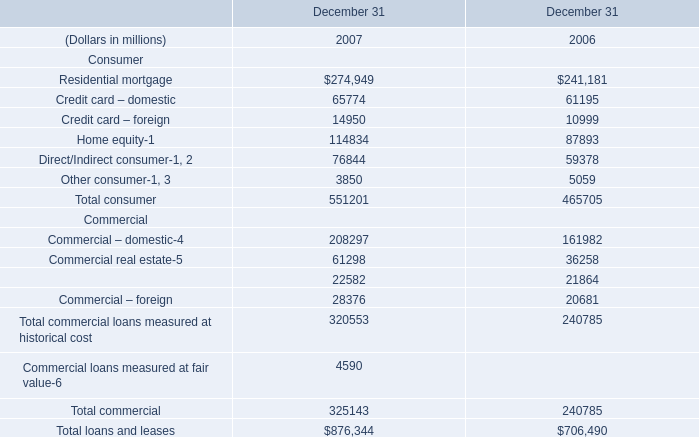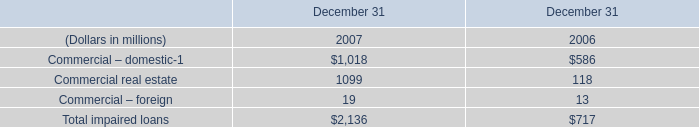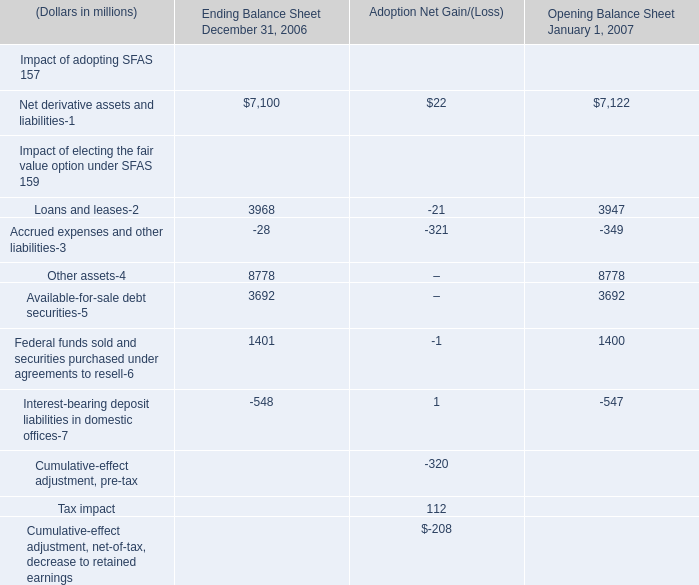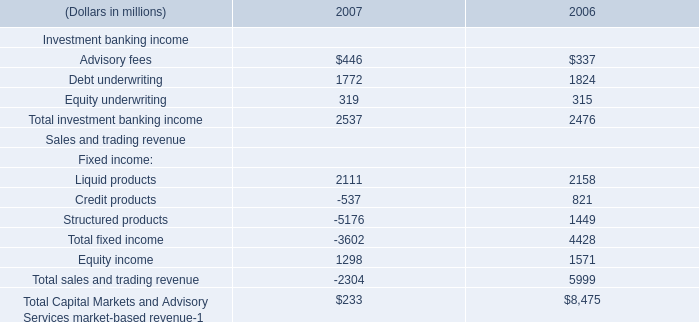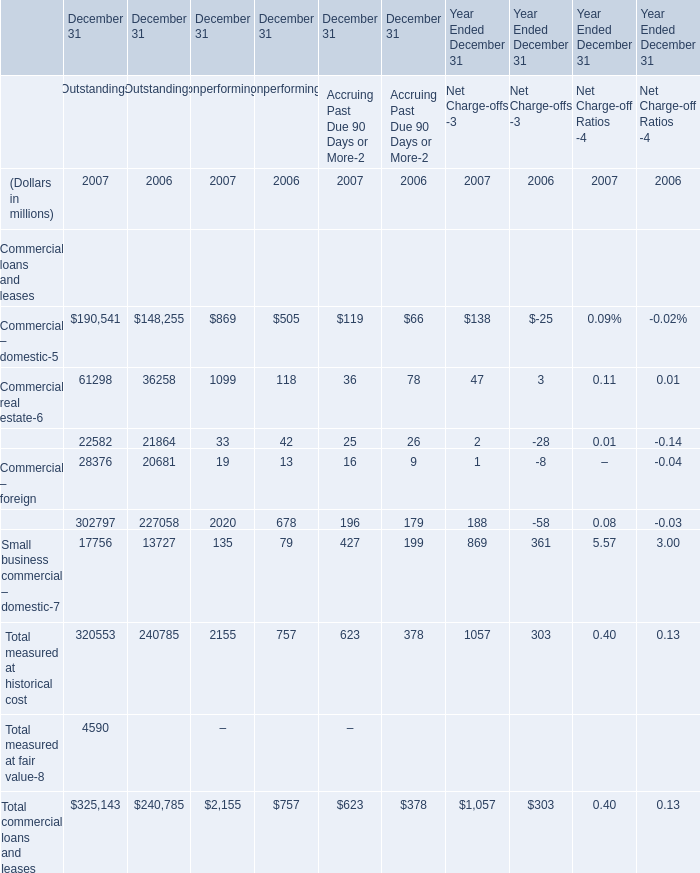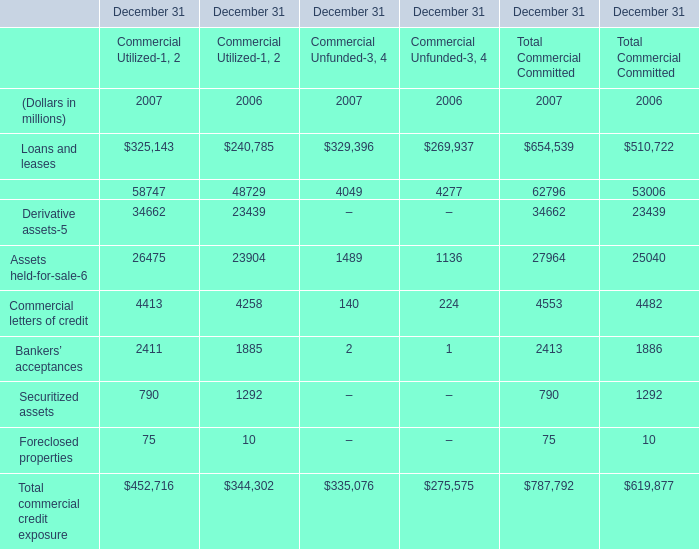What will Loans and leases reach in 2008 if it continues to grow at its current rate? (in million) 
Computations: (654539 + ((654539 - 510722) / 510722))
Answer: 654539.2816. 